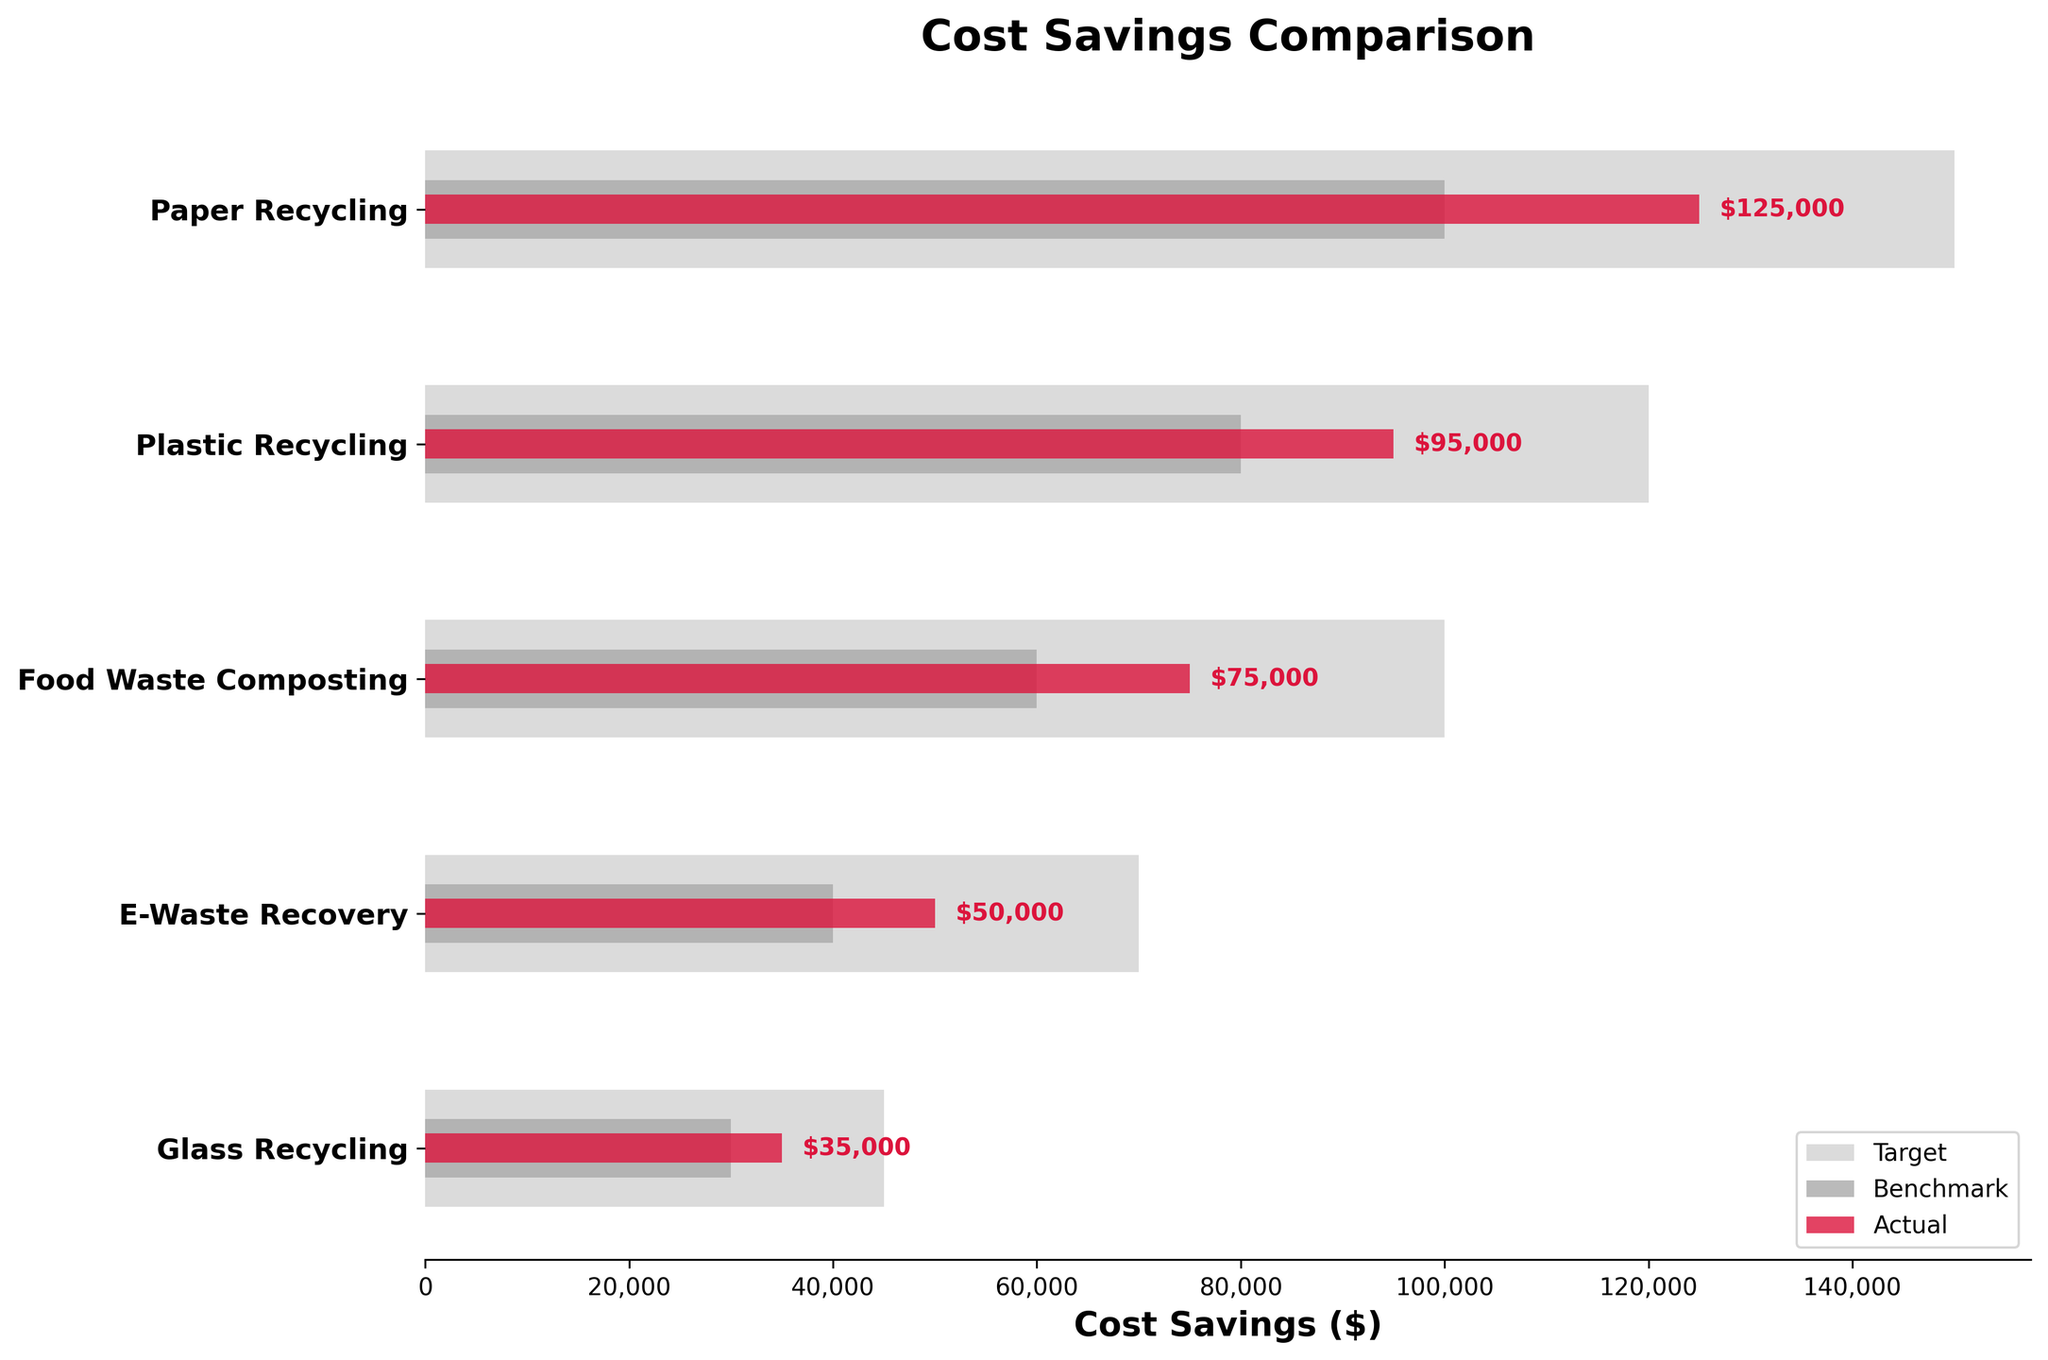What is the title of the chart? The title of the chart is shown at the top of the figure, providing context for what the chart is illustrating.
Answer: Cost Savings Comparison What does the crimson color bar represent in this chart? The crimson color bars are used to depict the actual cost savings for each category. This can be inferred from the smallest bar shown in crimson among the different shades.
Answer: Actual How many recycling programs are compared in the chart? The chart has labels for each recycling program on the y-axis, indicating the total number of programs compared. Counting these labels gives the answer.
Answer: 5 What is the target cost savings for Plastic Recycling? The target cost savings for each category is shown by the light grey bars. The value for Plastic Recycling can be directly read from the light grey bar hovering around the Plastic Recycling label.
Answer: $120,000 How much did the E-Waste Recovery program save compared to its target? First, identify the actual savings for E-Waste Recovery from the crimson bar, which is $50,000. Then identify the target savings using the light grey bar, which is $70,000. Subtract the actual savings from the target savings.
Answer: $20,000 What is the benchmark for Glass Recycling, and did it meet the target? The benchmark values are shown by the dark grey bars. For Glass Recycling, the benchmark is $30,000, and the target (light grey bar) is $45,000. To check if it met the target, compare the actual savings $35,000 with the target $45,000.
Answer: Benchmark: $30,000, Not met Which category has the highest benchmark value, and what is it? Look at the dark grey bars and identify the highest value from these bars. Identify which category it belongs to by reading the y-axis labels.
Answer: Paper Recycling, $100,000 Between Food Waste Composting and E-Waste Recovery, which performed closer to their respective targets? Calculate the difference between actual and target savings for both categories: Food Waste Composting (Target: $100,000, Actual: $75,000, Difference: $25,000) and E-Waste Recovery (Target: $70,000, Actual: $50,000, Difference: $20,000). The smaller the difference, the closer it performed to its target.
Answer: E-Waste Recovery What is the difference in actual savings between Paper Recycling and Glass Recycling? Identify the actual savings for both categories from the crimson bars: Paper Recycling is $125,000 and Glass Recycling is $35,000. Subtract the smaller value from the larger value.
Answer: $90,000 